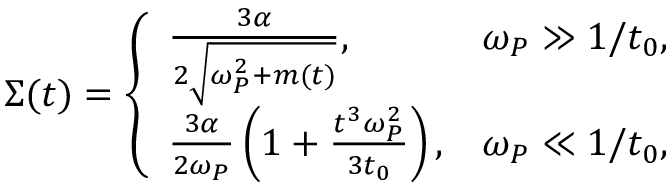Convert formula to latex. <formula><loc_0><loc_0><loc_500><loc_500>\begin{array} { r } { \Sigma ( t ) = \left \{ \begin{array} { l r } { \frac { { 3 } \alpha } { { 2 } \sqrt { \omega _ { P } ^ { 2 } + m ( t ) } } , } & { \omega _ { P } \gg 1 / t _ { 0 } , } \\ { \frac { { 3 } \alpha } { { 2 } \omega _ { P } } \left ( 1 + \frac { t ^ { 3 } \omega _ { P } ^ { 2 } } { 3 t _ { 0 } } \right ) , } & { \omega _ { P } \ll 1 / t _ { 0 } , } \end{array} } \end{array}</formula> 